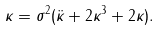Convert formula to latex. <formula><loc_0><loc_0><loc_500><loc_500>\kappa = \sigma ^ { 2 } ( \ddot { \kappa } + 2 \kappa ^ { 3 } + 2 \kappa ) .</formula> 